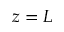<formula> <loc_0><loc_0><loc_500><loc_500>z = L</formula> 